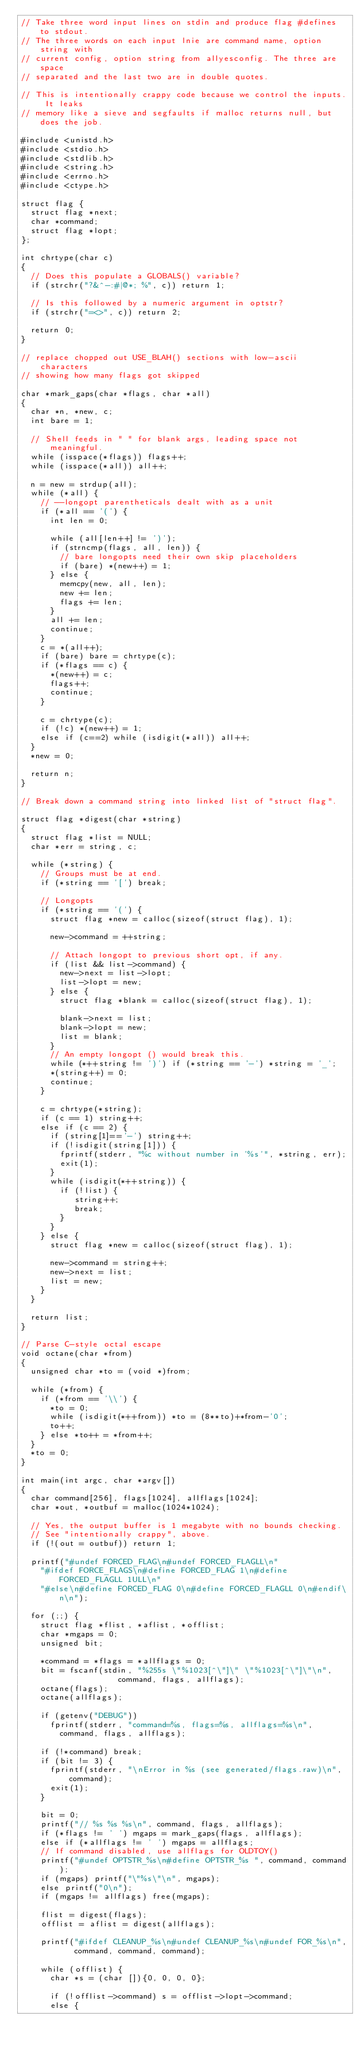Convert code to text. <code><loc_0><loc_0><loc_500><loc_500><_C_>// Take three word input lines on stdin and produce flag #defines to stdout.
// The three words on each input lnie are command name, option string with
// current config, option string from allyesconfig. The three are space
// separated and the last two are in double quotes.

// This is intentionally crappy code because we control the inputs. It leaks
// memory like a sieve and segfaults if malloc returns null, but does the job.

#include <unistd.h>
#include <stdio.h>
#include <stdlib.h>
#include <string.h>
#include <errno.h>
#include <ctype.h>

struct flag {
  struct flag *next;
  char *command;
  struct flag *lopt;
};

int chrtype(char c)
{
  // Does this populate a GLOBALS() variable?
  if (strchr("?&^-:#|@*; %", c)) return 1;

  // Is this followed by a numeric argument in optstr?
  if (strchr("=<>", c)) return 2;

  return 0;
}

// replace chopped out USE_BLAH() sections with low-ascii characters
// showing how many flags got skipped

char *mark_gaps(char *flags, char *all)
{
  char *n, *new, c;
  int bare = 1;

  // Shell feeds in " " for blank args, leading space not meaningful.
  while (isspace(*flags)) flags++;
  while (isspace(*all)) all++;

  n = new = strdup(all);
  while (*all) {
    // --longopt parentheticals dealt with as a unit
    if (*all == '(') {
      int len = 0;

      while (all[len++] != ')');
      if (strncmp(flags, all, len)) {
        // bare longopts need their own skip placeholders
        if (bare) *(new++) = 1;
      } else {
        memcpy(new, all, len);
        new += len;
        flags += len;
      }
      all += len;
      continue;
    }
    c = *(all++);
    if (bare) bare = chrtype(c);
    if (*flags == c) {
      *(new++) = c;
      flags++;
      continue;
    }

    c = chrtype(c);
    if (!c) *(new++) = 1;
    else if (c==2) while (isdigit(*all)) all++;
  }
  *new = 0;

  return n;
}

// Break down a command string into linked list of "struct flag".

struct flag *digest(char *string)
{
  struct flag *list = NULL;
  char *err = string, c;

  while (*string) {
    // Groups must be at end.
    if (*string == '[') break;

    // Longopts
    if (*string == '(') {
      struct flag *new = calloc(sizeof(struct flag), 1);

      new->command = ++string;

      // Attach longopt to previous short opt, if any.
      if (list && list->command) {
        new->next = list->lopt;
        list->lopt = new;
      } else {
        struct flag *blank = calloc(sizeof(struct flag), 1);

        blank->next = list;
        blank->lopt = new;
        list = blank;
      }
      // An empty longopt () would break this.
      while (*++string != ')') if (*string == '-') *string = '_';
      *(string++) = 0;
      continue;
    }

    c = chrtype(*string);
    if (c == 1) string++;
    else if (c == 2) {
      if (string[1]=='-') string++;
      if (!isdigit(string[1])) {
        fprintf(stderr, "%c without number in '%s'", *string, err);
        exit(1);
      }
      while (isdigit(*++string)) {
        if (!list) {
           string++;
           break;
        }
      }
    } else {
      struct flag *new = calloc(sizeof(struct flag), 1);

      new->command = string++;
      new->next = list;
      list = new;
    }
  }

  return list;
}

// Parse C-style octal escape
void octane(char *from)
{
  unsigned char *to = (void *)from;

  while (*from) {
    if (*from == '\\') {
      *to = 0;
      while (isdigit(*++from)) *to = (8**to)+*from-'0';
      to++;
    } else *to++ = *from++;
  }
  *to = 0;
}

int main(int argc, char *argv[])
{
  char command[256], flags[1024], allflags[1024];
  char *out, *outbuf = malloc(1024*1024);

  // Yes, the output buffer is 1 megabyte with no bounds checking.
  // See "intentionally crappy", above.
  if (!(out = outbuf)) return 1;

  printf("#undef FORCED_FLAG\n#undef FORCED_FLAGLL\n"
    "#ifdef FORCE_FLAGS\n#define FORCED_FLAG 1\n#define FORCED_FLAGLL 1ULL\n"
    "#else\n#define FORCED_FLAG 0\n#define FORCED_FLAGLL 0\n#endif\n\n");

  for (;;) {
    struct flag *flist, *aflist, *offlist;
    char *mgaps = 0;
    unsigned bit;

    *command = *flags = *allflags = 0;
    bit = fscanf(stdin, "%255s \"%1023[^\"]\" \"%1023[^\"]\"\n",
                    command, flags, allflags);
    octane(flags);
    octane(allflags);

    if (getenv("DEBUG"))
      fprintf(stderr, "command=%s, flags=%s, allflags=%s\n",
        command, flags, allflags);

    if (!*command) break;
    if (bit != 3) {
      fprintf(stderr, "\nError in %s (see generated/flags.raw)\n", command);
      exit(1);
    }

    bit = 0;
    printf("// %s %s %s\n", command, flags, allflags);
    if (*flags != ' ') mgaps = mark_gaps(flags, allflags);
    else if (*allflags != ' ') mgaps = allflags;
    // If command disabled, use allflags for OLDTOY()
    printf("#undef OPTSTR_%s\n#define OPTSTR_%s ", command, command);
    if (mgaps) printf("\"%s\"\n", mgaps);
    else printf("0\n");
    if (mgaps != allflags) free(mgaps);

    flist = digest(flags);
    offlist = aflist = digest(allflags);

    printf("#ifdef CLEANUP_%s\n#undef CLEANUP_%s\n#undef FOR_%s\n",
           command, command, command);

    while (offlist) {
      char *s = (char []){0, 0, 0, 0};

      if (!offlist->command) s = offlist->lopt->command;
      else {</code> 